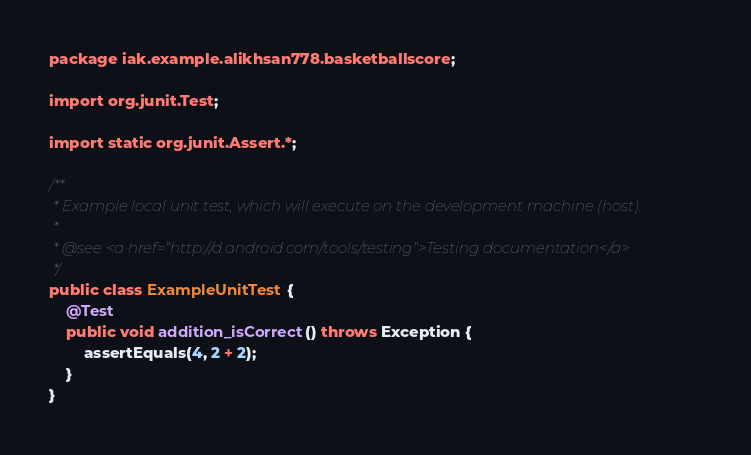Convert code to text. <code><loc_0><loc_0><loc_500><loc_500><_Java_>package iak.example.alikhsan778.basketballscore;

import org.junit.Test;

import static org.junit.Assert.*;

/**
 * Example local unit test, which will execute on the development machine (host).
 *
 * @see <a href="http://d.android.com/tools/testing">Testing documentation</a>
 */
public class ExampleUnitTest {
    @Test
    public void addition_isCorrect() throws Exception {
        assertEquals(4, 2 + 2);
    }
}</code> 